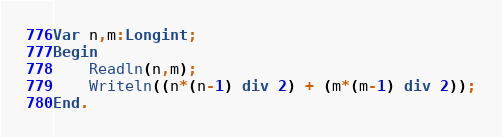Convert code to text. <code><loc_0><loc_0><loc_500><loc_500><_Pascal_>Var n,m:Longint;
Begin
    Readln(n,m);
    Writeln((n*(n-1) div 2) + (m*(m-1) div 2));
End.</code> 